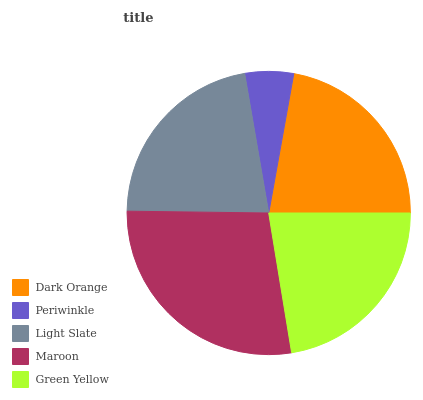Is Periwinkle the minimum?
Answer yes or no. Yes. Is Maroon the maximum?
Answer yes or no. Yes. Is Light Slate the minimum?
Answer yes or no. No. Is Light Slate the maximum?
Answer yes or no. No. Is Light Slate greater than Periwinkle?
Answer yes or no. Yes. Is Periwinkle less than Light Slate?
Answer yes or no. Yes. Is Periwinkle greater than Light Slate?
Answer yes or no. No. Is Light Slate less than Periwinkle?
Answer yes or no. No. Is Dark Orange the high median?
Answer yes or no. Yes. Is Dark Orange the low median?
Answer yes or no. Yes. Is Green Yellow the high median?
Answer yes or no. No. Is Maroon the low median?
Answer yes or no. No. 